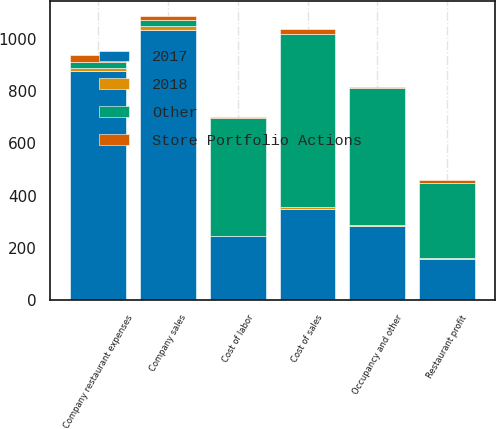<chart> <loc_0><loc_0><loc_500><loc_500><stacked_bar_chart><ecel><fcel>Company sales<fcel>Cost of sales<fcel>Cost of labor<fcel>Occupancy and other<fcel>Company restaurant expenses<fcel>Restaurant profit<nl><fcel>Other<fcel>21.5<fcel>664<fcel>451<fcel>524<fcel>21.5<fcel>289<nl><fcel>2017<fcel>1036<fcel>351<fcel>244<fcel>283<fcel>878<fcel>158<nl><fcel>Store Portfolio Actions<fcel>17<fcel>17<fcel>5<fcel>4<fcel>26<fcel>9<nl><fcel>2018<fcel>15<fcel>6<fcel>2<fcel>4<fcel>12<fcel>3<nl></chart> 